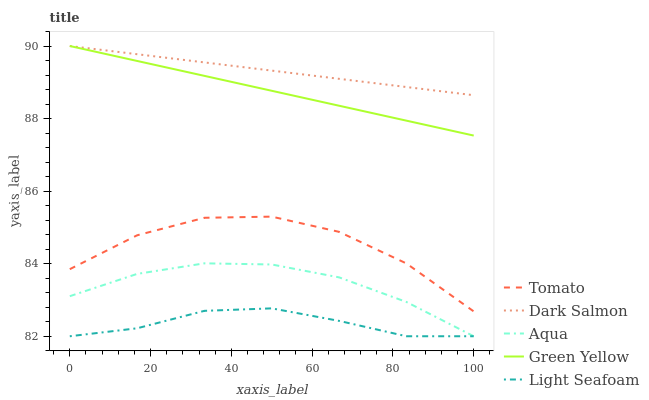Does Light Seafoam have the minimum area under the curve?
Answer yes or no. Yes. Does Dark Salmon have the maximum area under the curve?
Answer yes or no. Yes. Does Green Yellow have the minimum area under the curve?
Answer yes or no. No. Does Green Yellow have the maximum area under the curve?
Answer yes or no. No. Is Dark Salmon the smoothest?
Answer yes or no. Yes. Is Tomato the roughest?
Answer yes or no. Yes. Is Green Yellow the smoothest?
Answer yes or no. No. Is Green Yellow the roughest?
Answer yes or no. No. Does Aqua have the lowest value?
Answer yes or no. Yes. Does Green Yellow have the lowest value?
Answer yes or no. No. Does Dark Salmon have the highest value?
Answer yes or no. Yes. Does Aqua have the highest value?
Answer yes or no. No. Is Light Seafoam less than Tomato?
Answer yes or no. Yes. Is Dark Salmon greater than Light Seafoam?
Answer yes or no. Yes. Does Green Yellow intersect Dark Salmon?
Answer yes or no. Yes. Is Green Yellow less than Dark Salmon?
Answer yes or no. No. Is Green Yellow greater than Dark Salmon?
Answer yes or no. No. Does Light Seafoam intersect Tomato?
Answer yes or no. No. 